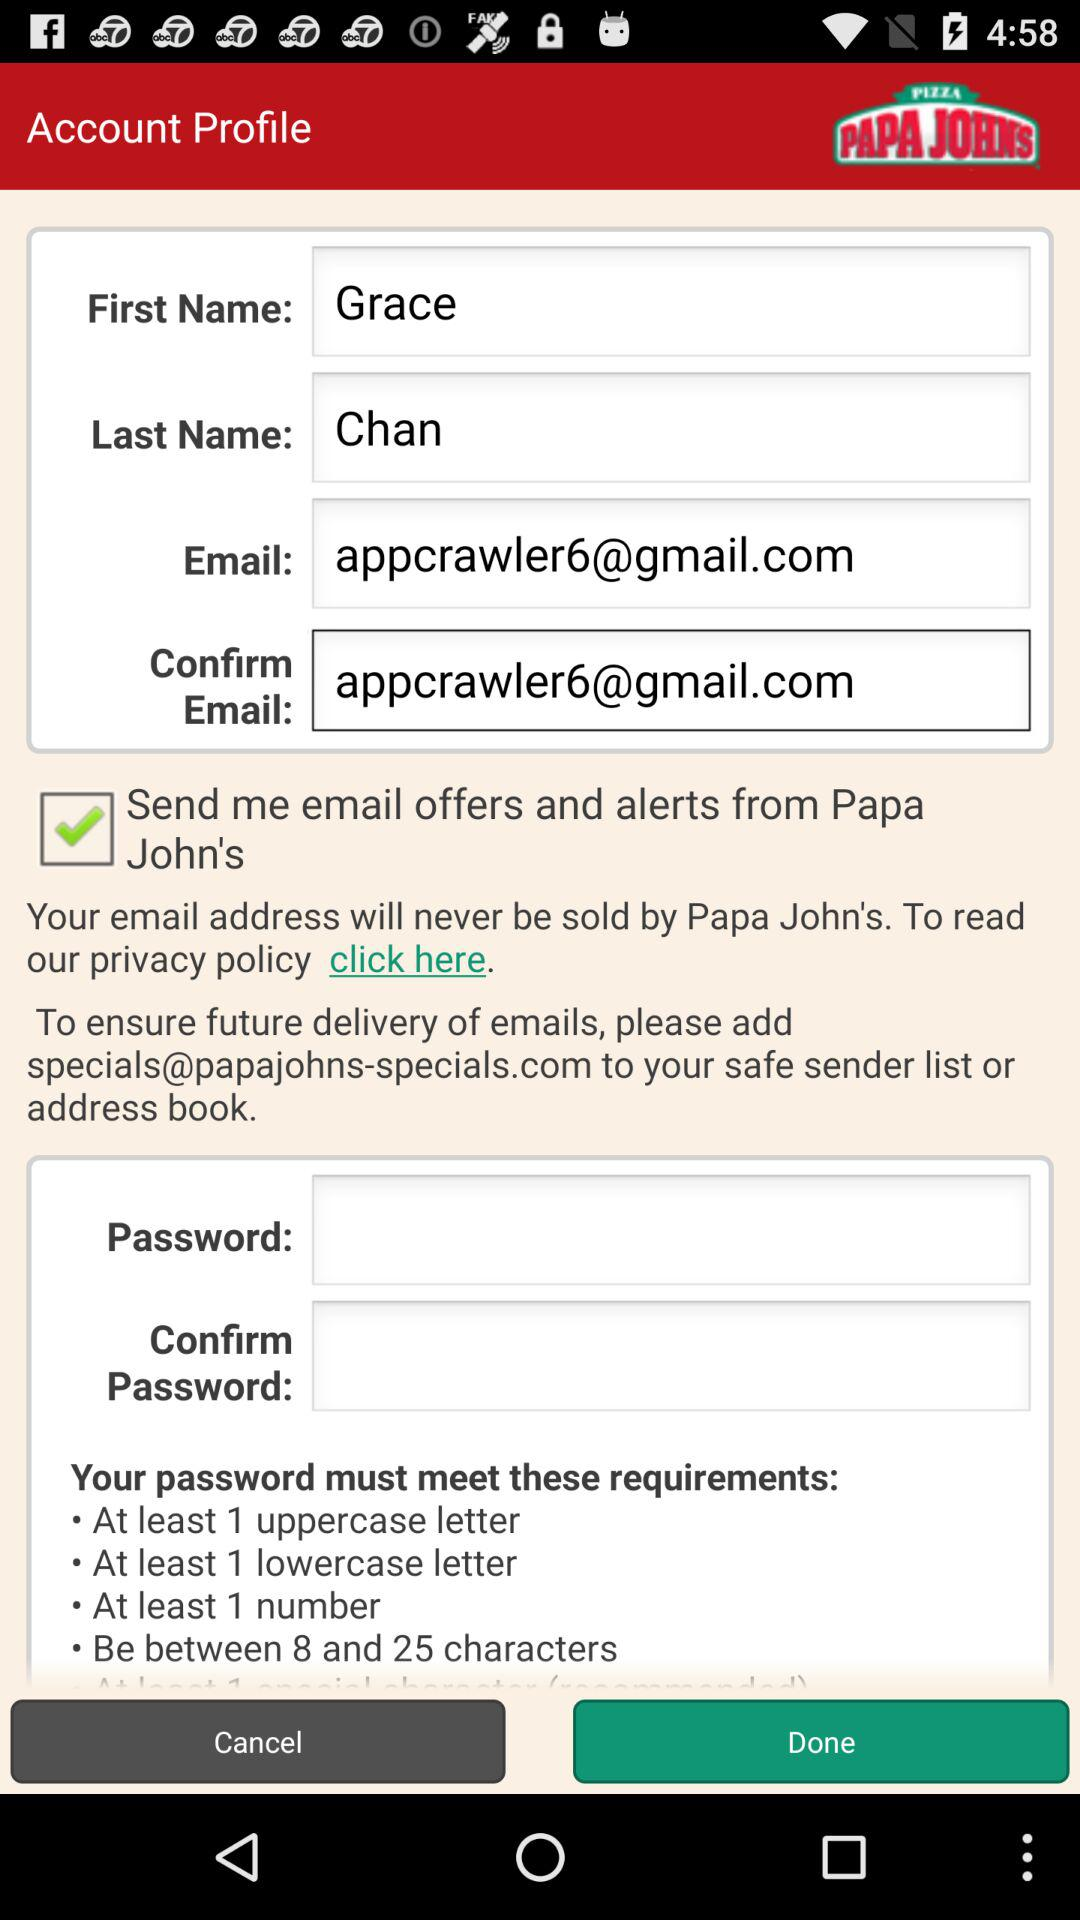What is the email address? The email address is appcrawler6@gmail.com. 